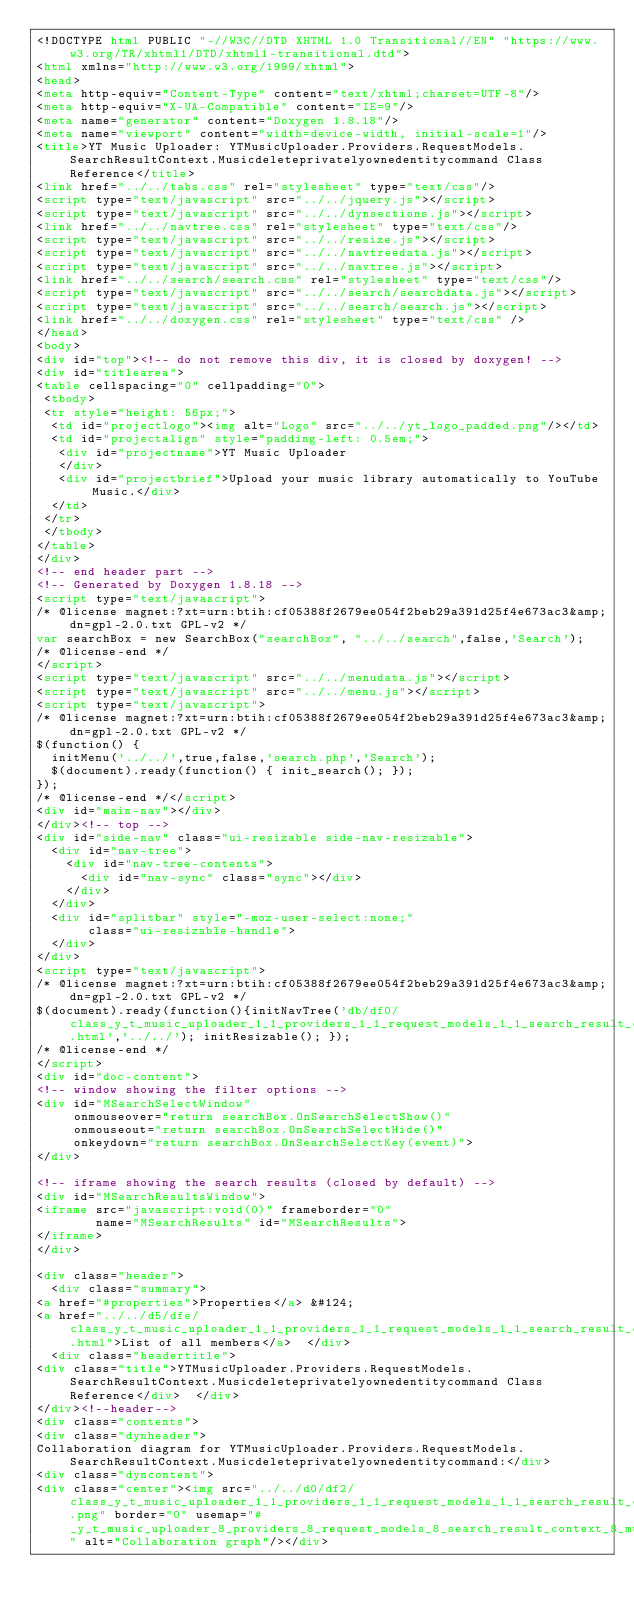Convert code to text. <code><loc_0><loc_0><loc_500><loc_500><_HTML_><!DOCTYPE html PUBLIC "-//W3C//DTD XHTML 1.0 Transitional//EN" "https://www.w3.org/TR/xhtml1/DTD/xhtml1-transitional.dtd">
<html xmlns="http://www.w3.org/1999/xhtml">
<head>
<meta http-equiv="Content-Type" content="text/xhtml;charset=UTF-8"/>
<meta http-equiv="X-UA-Compatible" content="IE=9"/>
<meta name="generator" content="Doxygen 1.8.18"/>
<meta name="viewport" content="width=device-width, initial-scale=1"/>
<title>YT Music Uploader: YTMusicUploader.Providers.RequestModels.SearchResultContext.Musicdeleteprivatelyownedentitycommand Class Reference</title>
<link href="../../tabs.css" rel="stylesheet" type="text/css"/>
<script type="text/javascript" src="../../jquery.js"></script>
<script type="text/javascript" src="../../dynsections.js"></script>
<link href="../../navtree.css" rel="stylesheet" type="text/css"/>
<script type="text/javascript" src="../../resize.js"></script>
<script type="text/javascript" src="../../navtreedata.js"></script>
<script type="text/javascript" src="../../navtree.js"></script>
<link href="../../search/search.css" rel="stylesheet" type="text/css"/>
<script type="text/javascript" src="../../search/searchdata.js"></script>
<script type="text/javascript" src="../../search/search.js"></script>
<link href="../../doxygen.css" rel="stylesheet" type="text/css" />
</head>
<body>
<div id="top"><!-- do not remove this div, it is closed by doxygen! -->
<div id="titlearea">
<table cellspacing="0" cellpadding="0">
 <tbody>
 <tr style="height: 56px;">
  <td id="projectlogo"><img alt="Logo" src="../../yt_logo_padded.png"/></td>
  <td id="projectalign" style="padding-left: 0.5em;">
   <div id="projectname">YT Music Uploader
   </div>
   <div id="projectbrief">Upload your music library automatically to YouTube Music.</div>
  </td>
 </tr>
 </tbody>
</table>
</div>
<!-- end header part -->
<!-- Generated by Doxygen 1.8.18 -->
<script type="text/javascript">
/* @license magnet:?xt=urn:btih:cf05388f2679ee054f2beb29a391d25f4e673ac3&amp;dn=gpl-2.0.txt GPL-v2 */
var searchBox = new SearchBox("searchBox", "../../search",false,'Search');
/* @license-end */
</script>
<script type="text/javascript" src="../../menudata.js"></script>
<script type="text/javascript" src="../../menu.js"></script>
<script type="text/javascript">
/* @license magnet:?xt=urn:btih:cf05388f2679ee054f2beb29a391d25f4e673ac3&amp;dn=gpl-2.0.txt GPL-v2 */
$(function() {
  initMenu('../../',true,false,'search.php','Search');
  $(document).ready(function() { init_search(); });
});
/* @license-end */</script>
<div id="main-nav"></div>
</div><!-- top -->
<div id="side-nav" class="ui-resizable side-nav-resizable">
  <div id="nav-tree">
    <div id="nav-tree-contents">
      <div id="nav-sync" class="sync"></div>
    </div>
  </div>
  <div id="splitbar" style="-moz-user-select:none;" 
       class="ui-resizable-handle">
  </div>
</div>
<script type="text/javascript">
/* @license magnet:?xt=urn:btih:cf05388f2679ee054f2beb29a391d25f4e673ac3&amp;dn=gpl-2.0.txt GPL-v2 */
$(document).ready(function(){initNavTree('db/df0/class_y_t_music_uploader_1_1_providers_1_1_request_models_1_1_search_result_context_1_1_musicdeleteprivatelyownedentitycommand.html','../../'); initResizable(); });
/* @license-end */
</script>
<div id="doc-content">
<!-- window showing the filter options -->
<div id="MSearchSelectWindow"
     onmouseover="return searchBox.OnSearchSelectShow()"
     onmouseout="return searchBox.OnSearchSelectHide()"
     onkeydown="return searchBox.OnSearchSelectKey(event)">
</div>

<!-- iframe showing the search results (closed by default) -->
<div id="MSearchResultsWindow">
<iframe src="javascript:void(0)" frameborder="0" 
        name="MSearchResults" id="MSearchResults">
</iframe>
</div>

<div class="header">
  <div class="summary">
<a href="#properties">Properties</a> &#124;
<a href="../../d5/dfe/class_y_t_music_uploader_1_1_providers_1_1_request_models_1_1_search_result_context_1_1_musicdel79240e58c88d16c0617c0df9dd23c759.html">List of all members</a>  </div>
  <div class="headertitle">
<div class="title">YTMusicUploader.Providers.RequestModels.SearchResultContext.Musicdeleteprivatelyownedentitycommand Class Reference</div>  </div>
</div><!--header-->
<div class="contents">
<div class="dynheader">
Collaboration diagram for YTMusicUploader.Providers.RequestModels.SearchResultContext.Musicdeleteprivatelyownedentitycommand:</div>
<div class="dyncontent">
<div class="center"><img src="../../d0/df2/class_y_t_music_uploader_1_1_providers_1_1_request_models_1_1_search_result_context_1_1_musicdel9ab8fea7195c0fa4878fa9337be96406.png" border="0" usemap="#_y_t_music_uploader_8_providers_8_request_models_8_search_result_context_8_musicdeleteprivatelyownedentitycommand_coll__map" alt="Collaboration graph"/></div></code> 